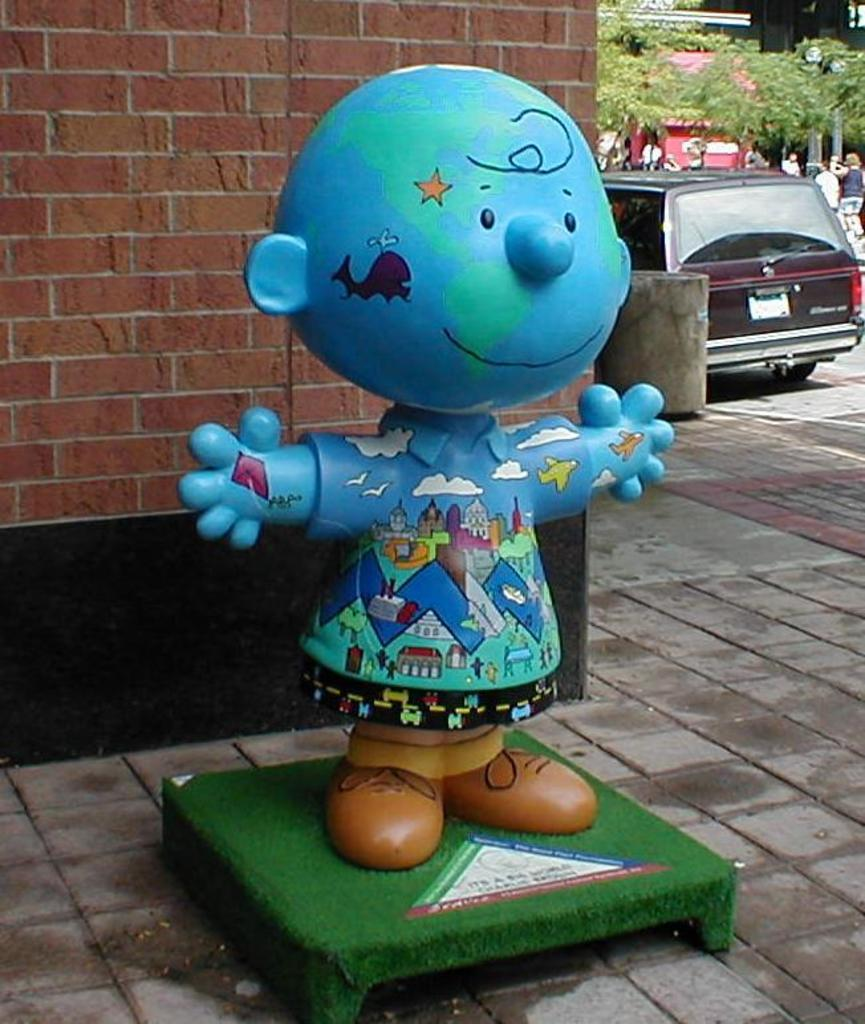What type of structure can be seen in the image? There is a brick wall in the image. What is the statue made of and what is it doing? The statue is blue and appears to be painted, and it is standing in the image. What can be seen on the right side of the image? Trees and a vehicle are visible on the right side of the image. How many worms are crawling on the blue statue in the image? There are no worms present in the image, as it features a brick wall, a blue statue, trees, and a vehicle. What is the size of the statement in the image? There is no statement present in the image, so it is not possible to determine its size. 